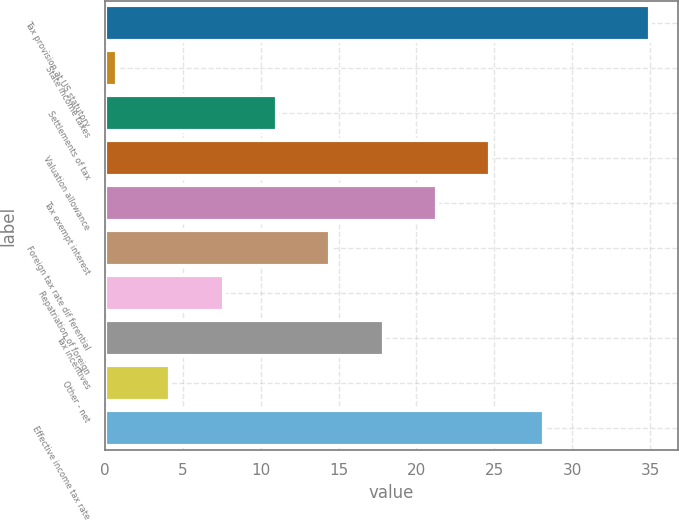Convert chart to OTSL. <chart><loc_0><loc_0><loc_500><loc_500><bar_chart><fcel>Tax provision at US statutory<fcel>State income taxes<fcel>Settlements of tax<fcel>Valuation allowance<fcel>Tax exempt interest<fcel>Foreign tax rate dif ferential<fcel>Repatriation of foreign<fcel>Tax incentives<fcel>Other - net<fcel>Effective income tax rate<nl><fcel>35<fcel>0.8<fcel>11.06<fcel>24.74<fcel>21.32<fcel>14.48<fcel>7.64<fcel>17.9<fcel>4.22<fcel>28.16<nl></chart> 